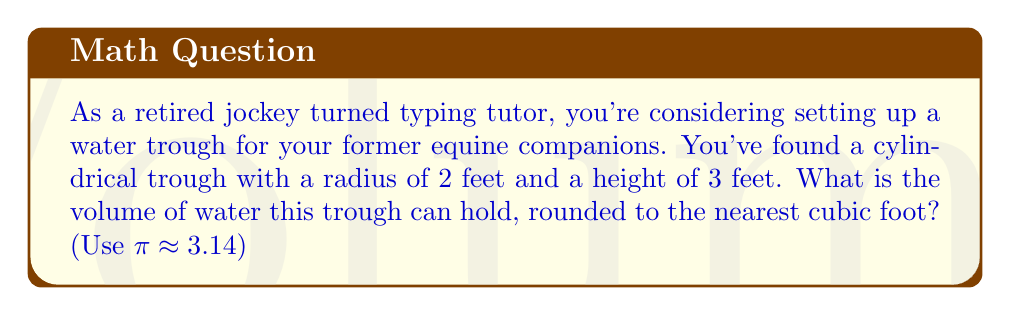Teach me how to tackle this problem. To find the volume of a cylindrical water trough, we need to use the formula for the volume of a cylinder:

$$V = \pi r^2 h$$

Where:
$V$ = volume
$r$ = radius of the base
$h$ = height of the cylinder

Given:
$r = 2$ feet
$h = 3$ feet
$\pi \approx 3.14$

Let's substitute these values into the formula:

$$V = \pi r^2 h$$
$$V = 3.14 \times (2\text{ ft})^2 \times 3\text{ ft}$$
$$V = 3.14 \times 4\text{ ft}^2 \times 3\text{ ft}$$
$$V = 37.68\text{ ft}^3$$

Rounding to the nearest cubic foot:

$$V \approx 38\text{ ft}^3$$

[asy]
import geometry;

size(200);
real r = 2;
real h = 3;

path base = circle((0,0), r);
path top = circle((0,h), r);

draw(base);
draw(top);
draw((r,0)--(r,h));
draw((-r,0)--(-r,h));

label("r", (r/2,0), E);
label("h", (r,h/2), E);

draw((0,0)--(r,0), arrow=Arrow(TeXHead));
draw((r,0)--(r,h), arrow=Arrow(TeXHead));
[/asy]
Answer: 38 cubic feet 